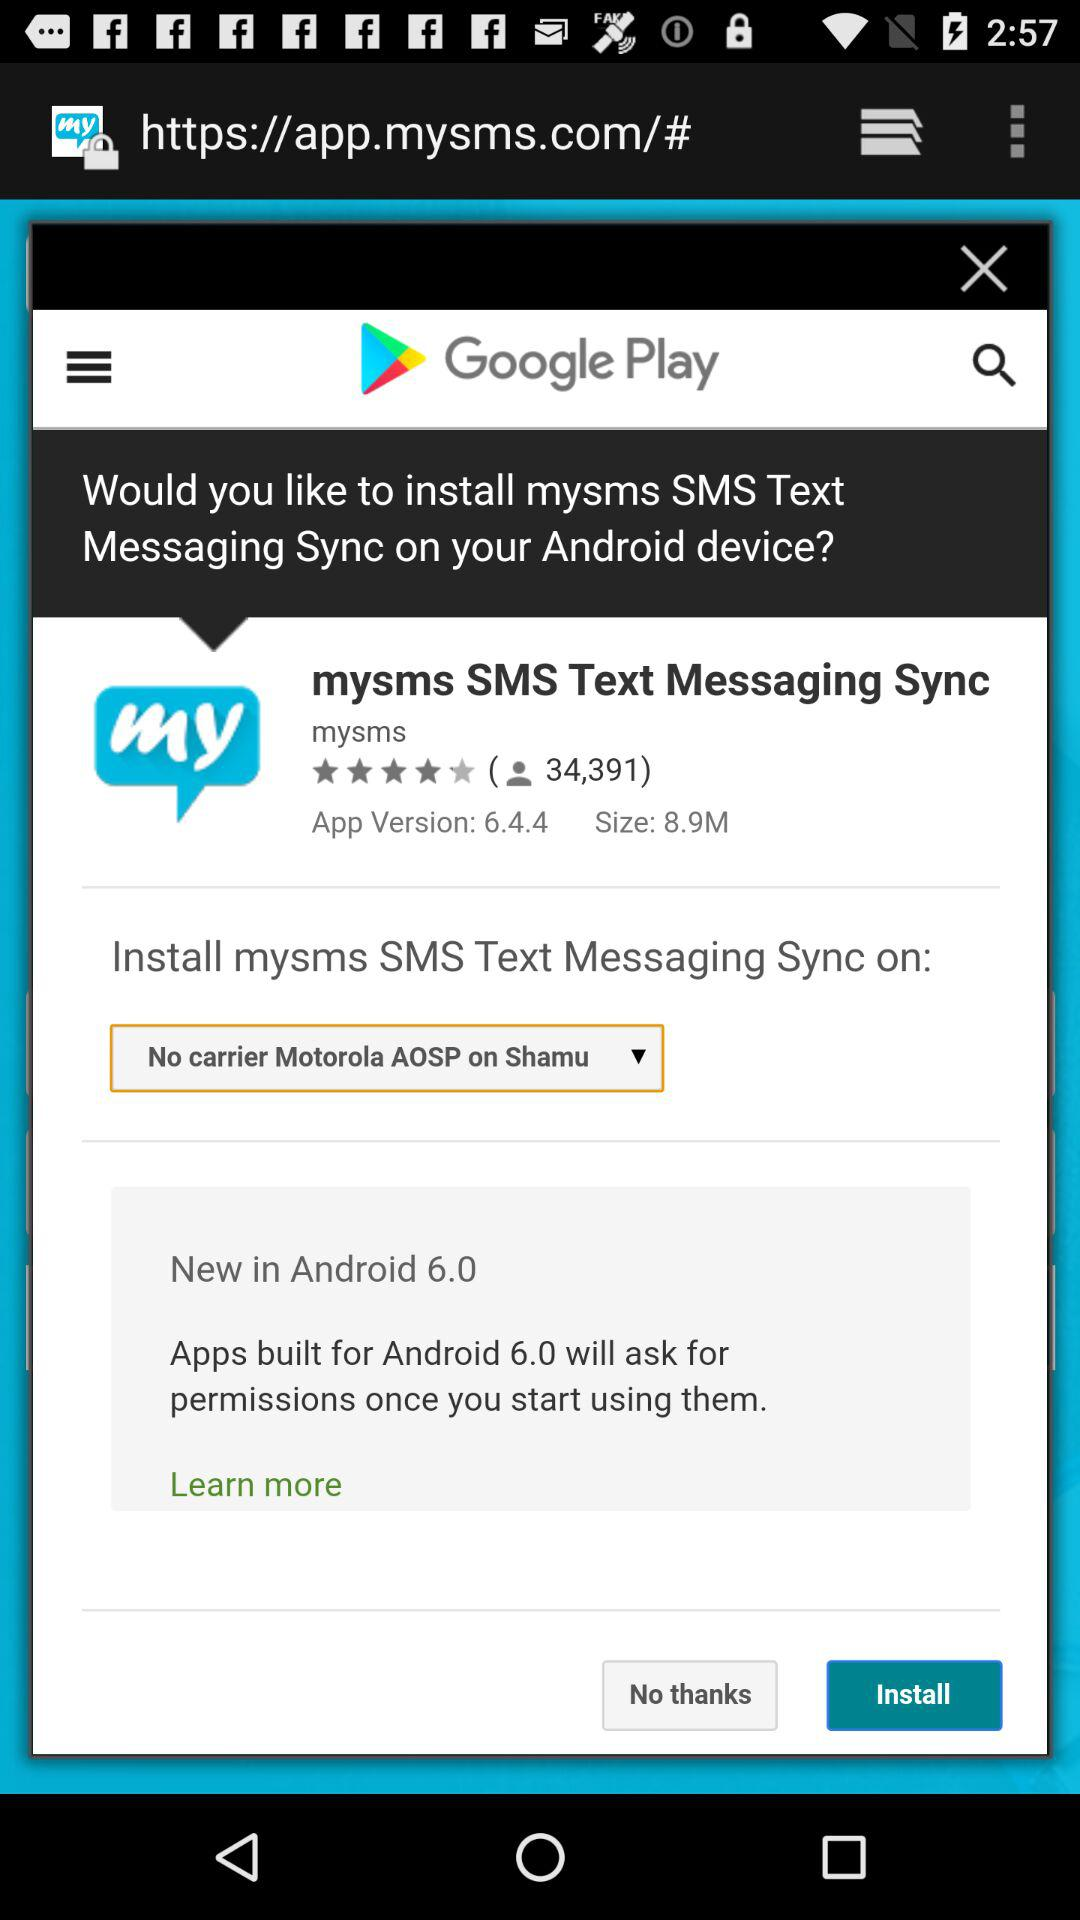What is the name of the application? The application name is "mysms SMS Text Messaging Sync". 